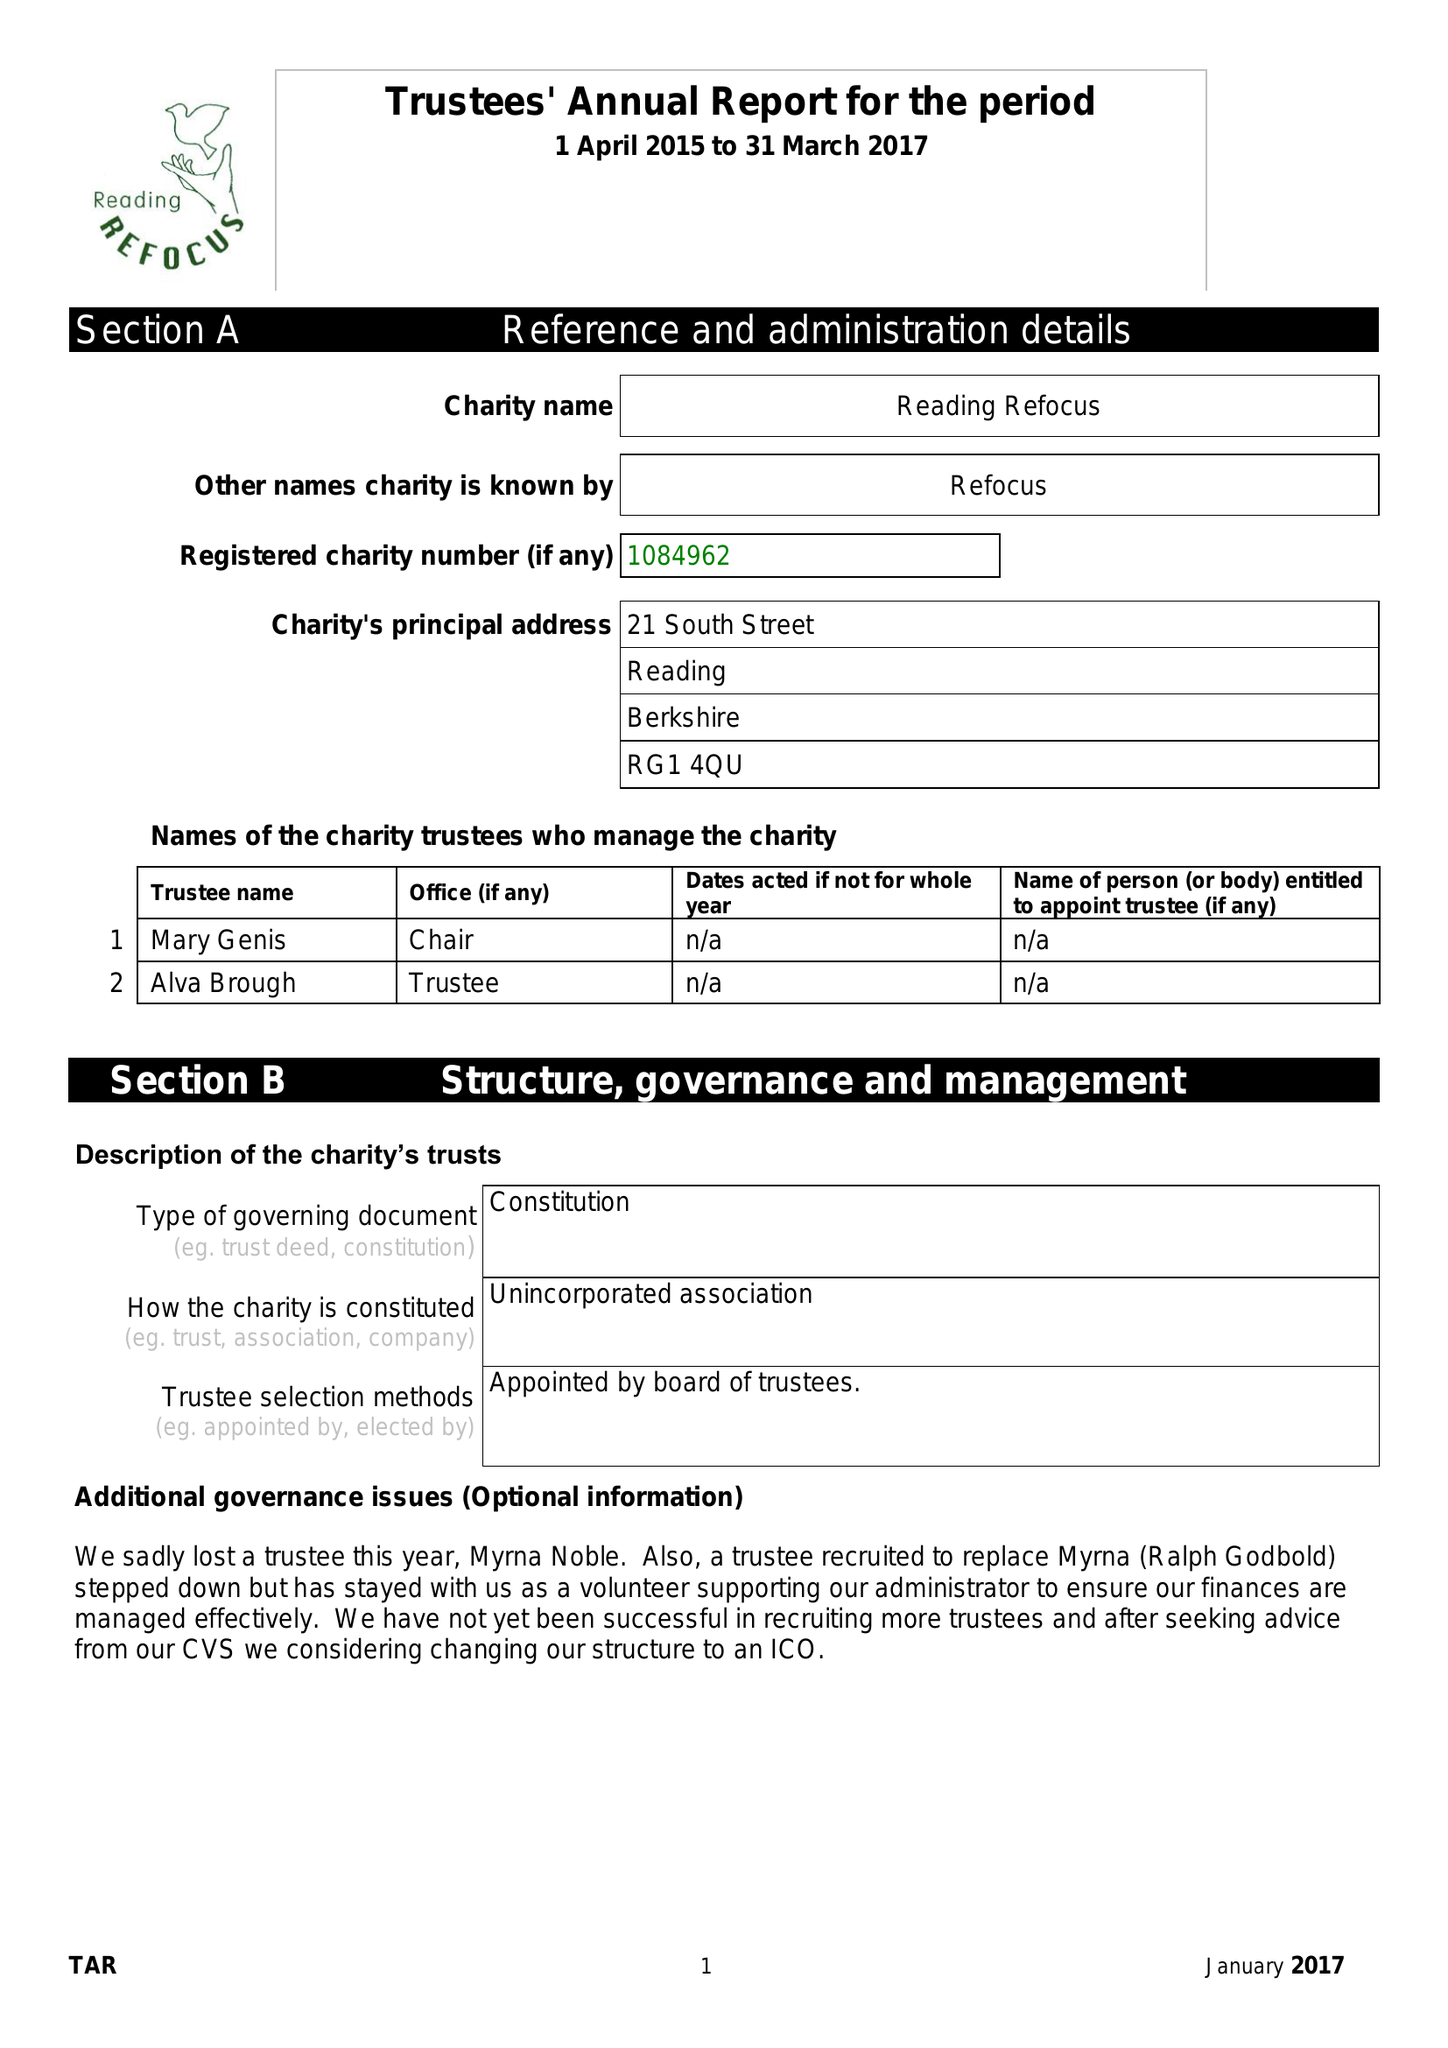What is the value for the spending_annually_in_british_pounds?
Answer the question using a single word or phrase. 26692.00 